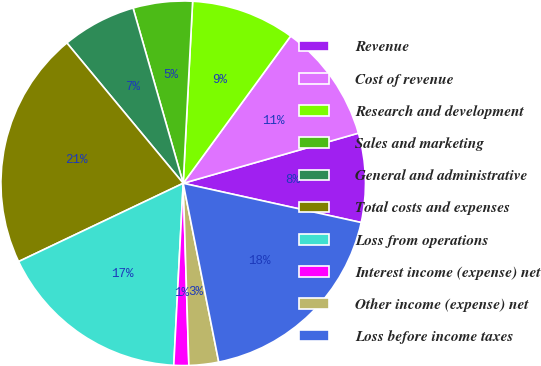Convert chart to OTSL. <chart><loc_0><loc_0><loc_500><loc_500><pie_chart><fcel>Revenue<fcel>Cost of revenue<fcel>Research and development<fcel>Sales and marketing<fcel>General and administrative<fcel>Total costs and expenses<fcel>Loss from operations<fcel>Interest income (expense) net<fcel>Other income (expense) net<fcel>Loss before income taxes<nl><fcel>7.89%<fcel>10.53%<fcel>9.21%<fcel>5.26%<fcel>6.58%<fcel>21.05%<fcel>17.11%<fcel>1.32%<fcel>2.63%<fcel>18.42%<nl></chart> 